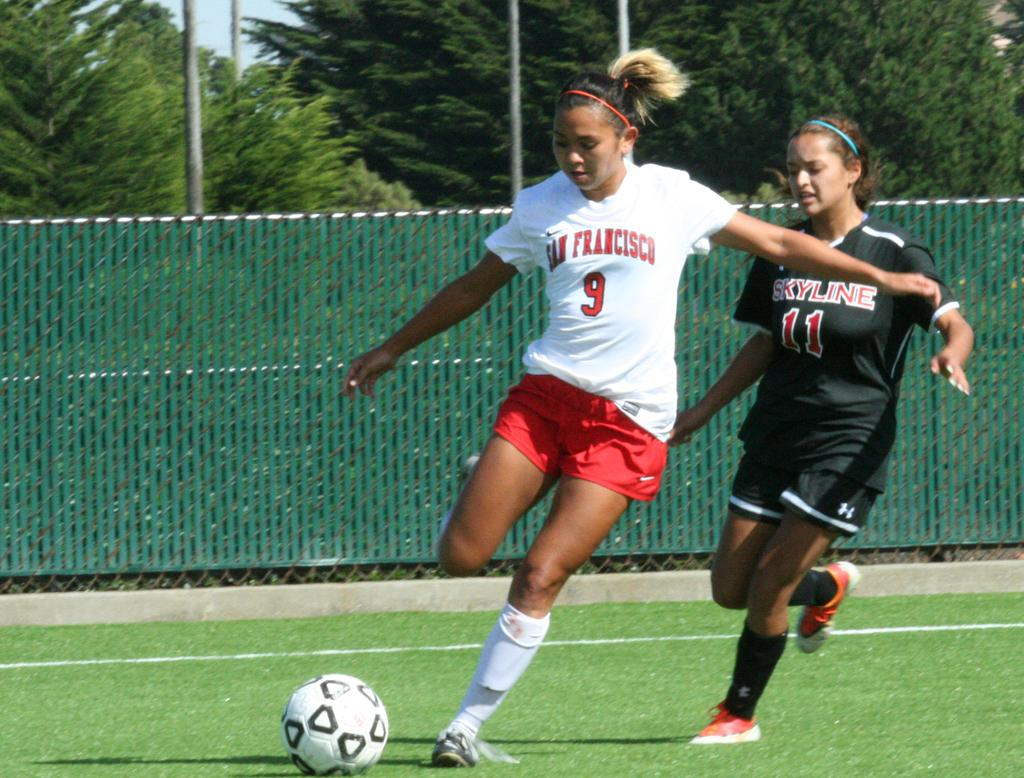What are the two people in the image doing? The two people in the image are running. What is on the ground near the people? There is a ball on the ground in the image. What can be seen in the background of the image? There is a fence and trees in the background of the image. What else is present in the image besides the people and the ball? There are poles in the image. Can you see a yak in the image? No, there is no yak present in the image. What is the purpose of the people running in the image? The purpose of the people running cannot be determined from the image alone, as there is no context provided. 